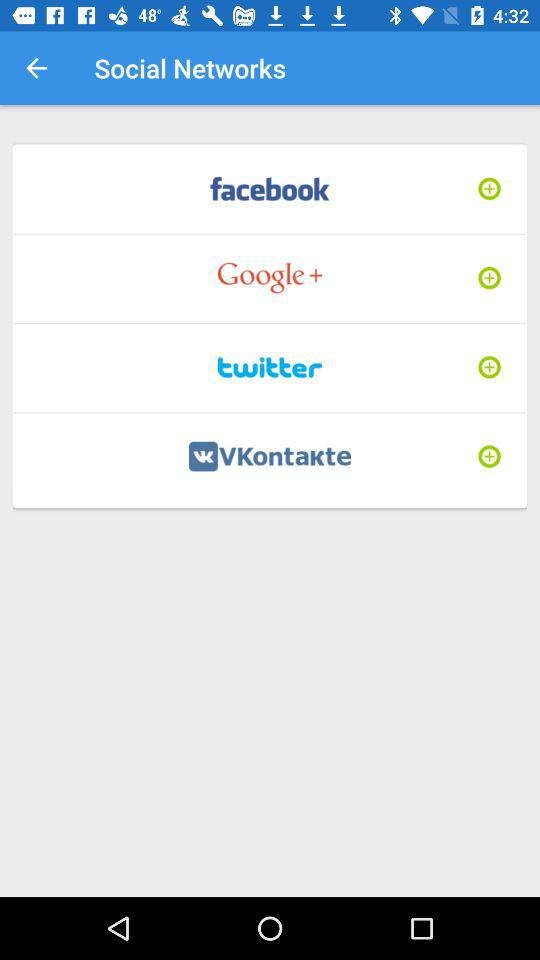How many social networks are available?
Answer the question using a single word or phrase. 4 